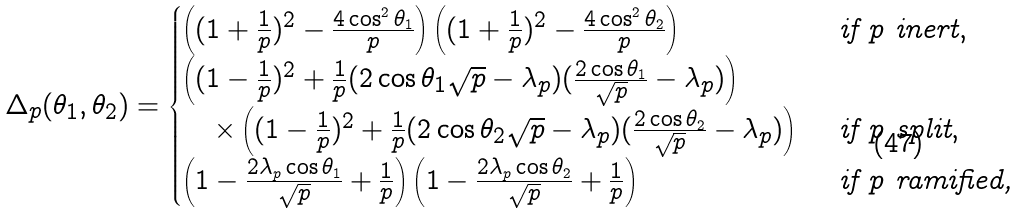Convert formula to latex. <formula><loc_0><loc_0><loc_500><loc_500>\Delta _ { p } ( \theta _ { 1 } , \theta _ { 2 } ) = \begin{cases} \left ( ( 1 + \frac { 1 } { p } ) ^ { 2 } - \frac { 4 \cos ^ { 2 } \theta _ { 1 } } { p } \right ) \left ( ( 1 + \frac { 1 } { p } ) ^ { 2 } - \frac { 4 \cos ^ { 2 } \theta _ { 2 } } { p } \right ) & \text { if } p \text { inert} , \\ \left ( ( 1 - \frac { 1 } { p } ) ^ { 2 } + \frac { 1 } { p } ( 2 \cos \theta _ { 1 } \sqrt { p } - \lambda _ { p } ) ( \frac { 2 \cos \theta _ { 1 } } { \sqrt { p } } - \lambda _ { p } ) \right ) \\ \quad \times \left ( ( 1 - \frac { 1 } { p } ) ^ { 2 } + \frac { 1 } { p } ( 2 \cos \theta _ { 2 } \sqrt { p } - \lambda _ { p } ) ( \frac { 2 \cos \theta _ { 2 } } { \sqrt { p } } - \lambda _ { p } ) \right ) & \text { if } p \text { split} , \\ \left ( 1 - \frac { 2 \lambda _ { p } \cos \theta _ { 1 } } { \sqrt { p } } + \frac { 1 } { p } \right ) \left ( 1 - \frac { 2 \lambda _ { p } \cos \theta _ { 2 } } { \sqrt { p } } + \frac { 1 } { p } \right ) & \text { if } p \text { ramified,} \end{cases}</formula> 